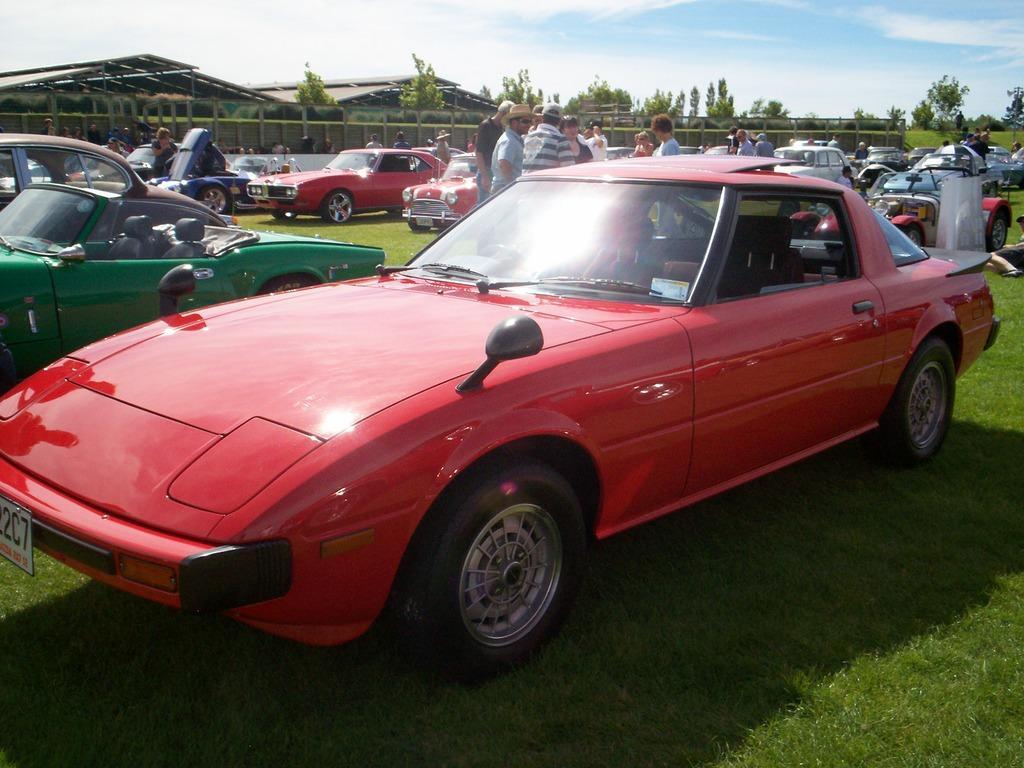Describe this image in one or two sentences. In this image we can see vehicles. On the ground there is grass. In the back there are people. Also there are buildings and trees. And there is sky with clouds. 